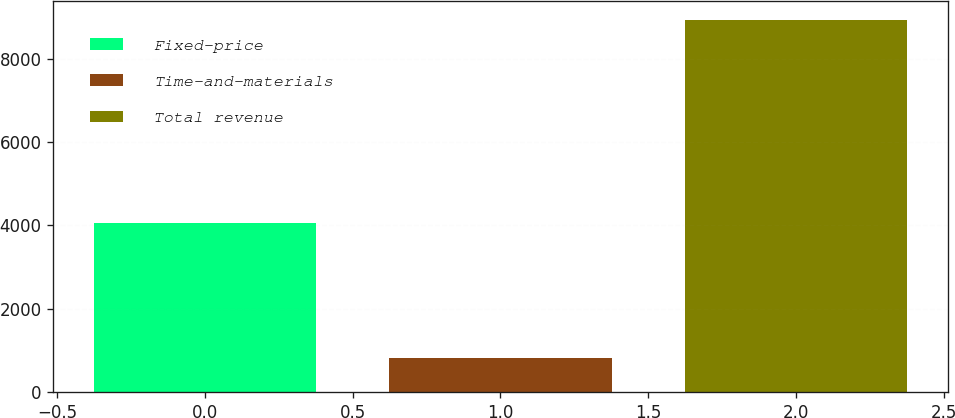Convert chart to OTSL. <chart><loc_0><loc_0><loc_500><loc_500><bar_chart><fcel>Fixed-price<fcel>Time-and-materials<fcel>Total revenue<nl><fcel>4066<fcel>834<fcel>8929<nl></chart> 